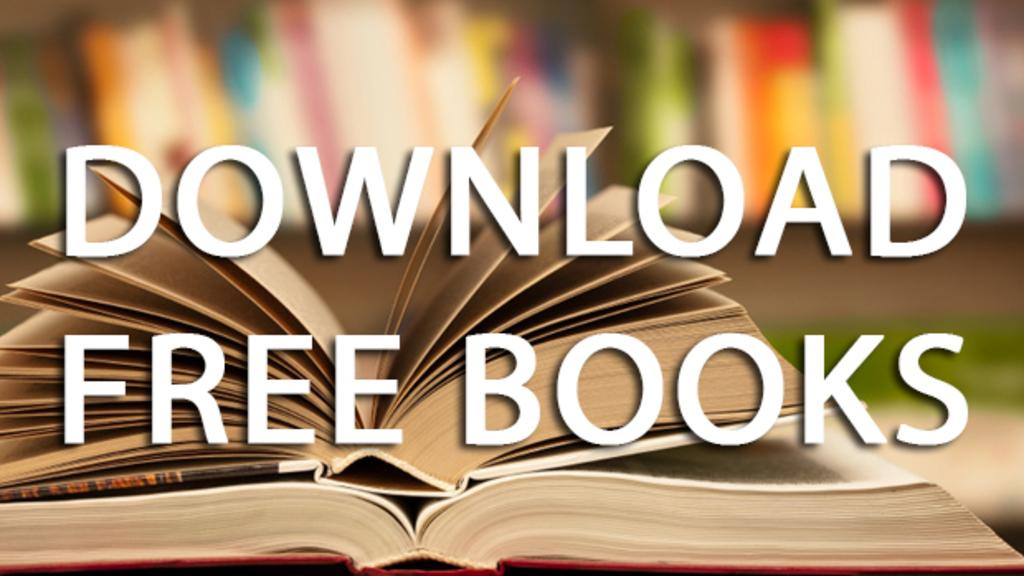<image>
Share a concise interpretation of the image provided. A sign tells us that we can download free books. 